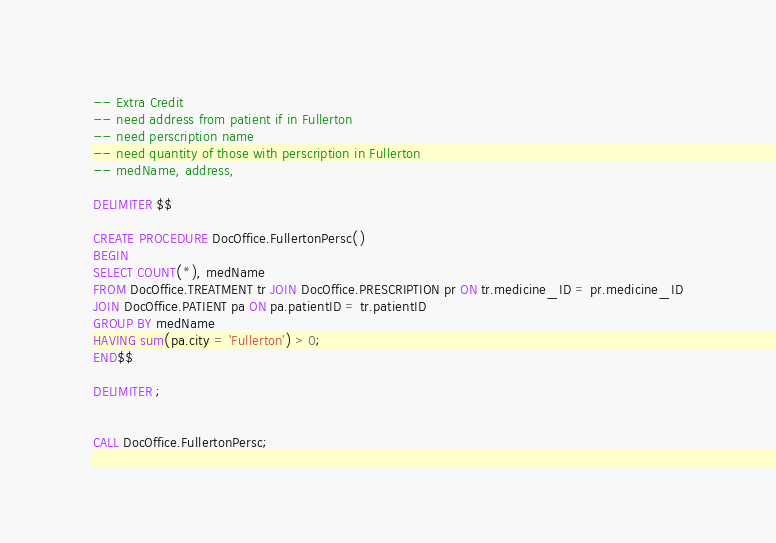Convert code to text. <code><loc_0><loc_0><loc_500><loc_500><_SQL_>-- Extra Credit
-- need address from patient if in Fullerton
-- need perscription name
-- need quantity of those with perscription in Fullerton
-- medName, address,

DELIMITER $$

CREATE PROCEDURE DocOffice.FullertonPersc()
BEGIN
SELECT COUNT(*), medName
FROM DocOffice.TREATMENT tr JOIN DocOffice.PRESCRIPTION pr ON tr.medicine_ID = pr.medicine_ID
JOIN DocOffice.PATIENT pa ON pa.patientID = tr.patientID
GROUP BY medName
HAVING sum(pa.city = 'Fullerton') > 0;
END$$

DELIMITER ;


CALL DocOffice.FullertonPersc;</code> 